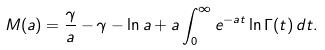Convert formula to latex. <formula><loc_0><loc_0><loc_500><loc_500>M ( a ) = \frac { \gamma } { a } - \gamma - \ln a + a \int _ { 0 } ^ { \infty } e ^ { - a t } \ln \Gamma ( t ) \, d t .</formula> 